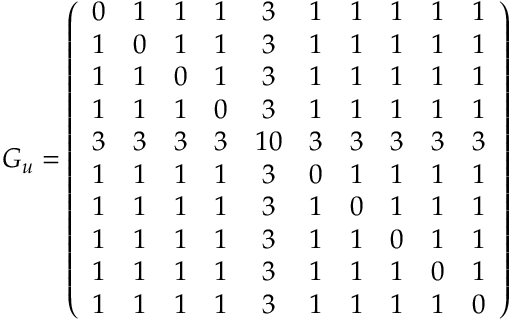Convert formula to latex. <formula><loc_0><loc_0><loc_500><loc_500>G _ { u } = \left ( \begin{array} { c c c c c c c c c c } { 0 } & { 1 } & { 1 } & { 1 } & { 3 } & { 1 } & { 1 } & { 1 } & { 1 } & { 1 } \\ { 1 } & { 0 } & { 1 } & { 1 } & { 3 } & { 1 } & { 1 } & { 1 } & { 1 } & { 1 } \\ { 1 } & { 1 } & { 0 } & { 1 } & { 3 } & { 1 } & { 1 } & { 1 } & { 1 } & { 1 } \\ { 1 } & { 1 } & { 1 } & { 0 } & { 3 } & { 1 } & { 1 } & { 1 } & { 1 } & { 1 } \\ { 3 } & { 3 } & { 3 } & { 3 } & { 1 0 } & { 3 } & { 3 } & { 3 } & { 3 } & { 3 } \\ { 1 } & { 1 } & { 1 } & { 1 } & { 3 } & { 0 } & { 1 } & { 1 } & { 1 } & { 1 } \\ { 1 } & { 1 } & { 1 } & { 1 } & { 3 } & { 1 } & { 0 } & { 1 } & { 1 } & { 1 } \\ { 1 } & { 1 } & { 1 } & { 1 } & { 3 } & { 1 } & { 1 } & { 0 } & { 1 } & { 1 } \\ { 1 } & { 1 } & { 1 } & { 1 } & { 3 } & { 1 } & { 1 } & { 1 } & { 0 } & { 1 } \\ { 1 } & { 1 } & { 1 } & { 1 } & { 3 } & { 1 } & { 1 } & { 1 } & { 1 } & { 0 } \end{array} \right )</formula> 